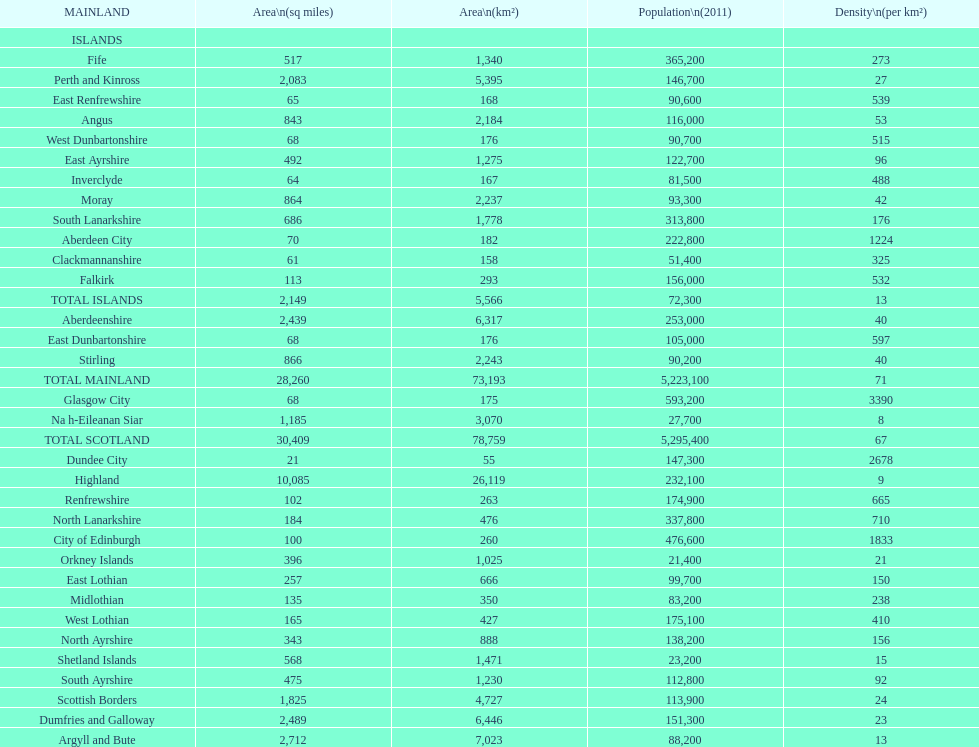Which is the only subdivision to have a greater area than argyll and bute? Highland. 